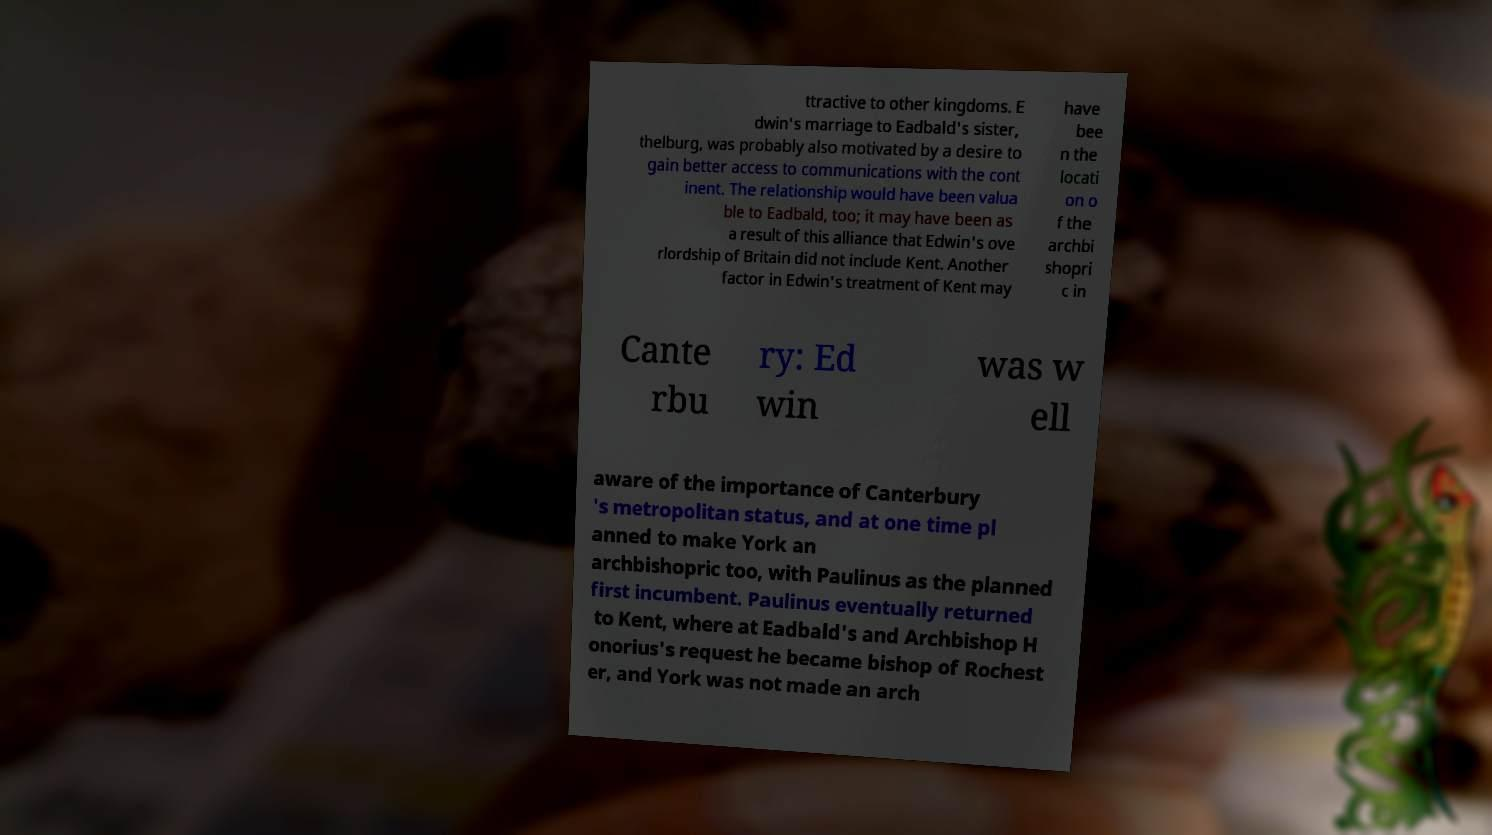Could you extract and type out the text from this image? ttractive to other kingdoms. E dwin's marriage to Eadbald's sister, thelburg, was probably also motivated by a desire to gain better access to communications with the cont inent. The relationship would have been valua ble to Eadbald, too; it may have been as a result of this alliance that Edwin's ove rlordship of Britain did not include Kent. Another factor in Edwin's treatment of Kent may have bee n the locati on o f the archbi shopri c in Cante rbu ry: Ed win was w ell aware of the importance of Canterbury 's metropolitan status, and at one time pl anned to make York an archbishopric too, with Paulinus as the planned first incumbent. Paulinus eventually returned to Kent, where at Eadbald's and Archbishop H onorius's request he became bishop of Rochest er, and York was not made an arch 